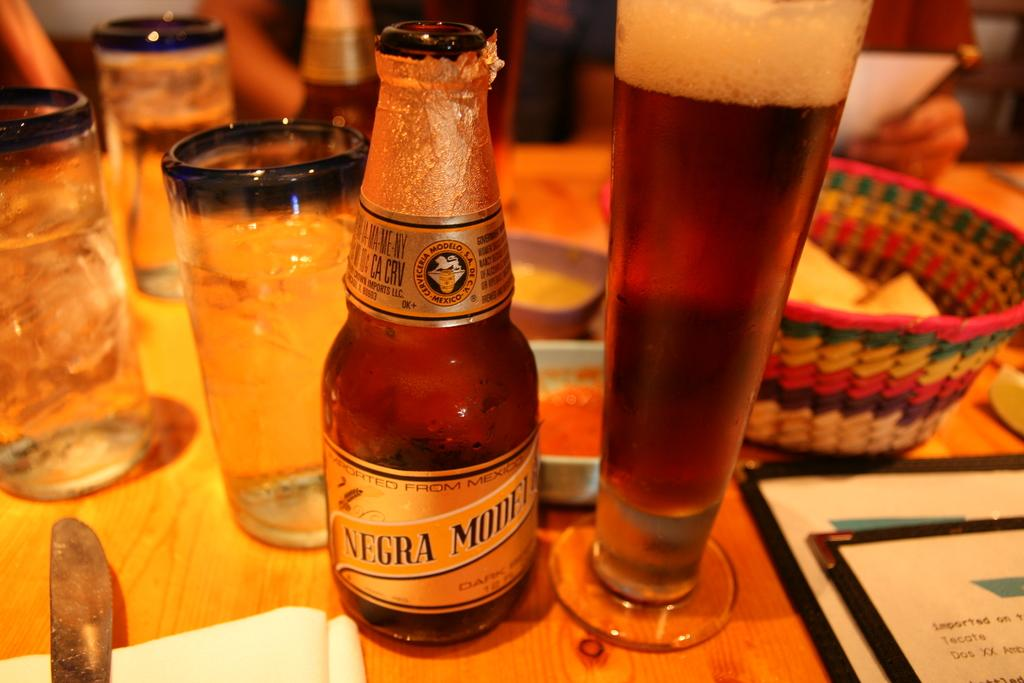What object is on the table in the image? There is a basket on the table in the image. What else can be seen on the table? There is a bottle and glasses on the table in the image. How many gloves are in the basket on the table? There is no mention of gloves in the image; the basket contains unspecified items. 